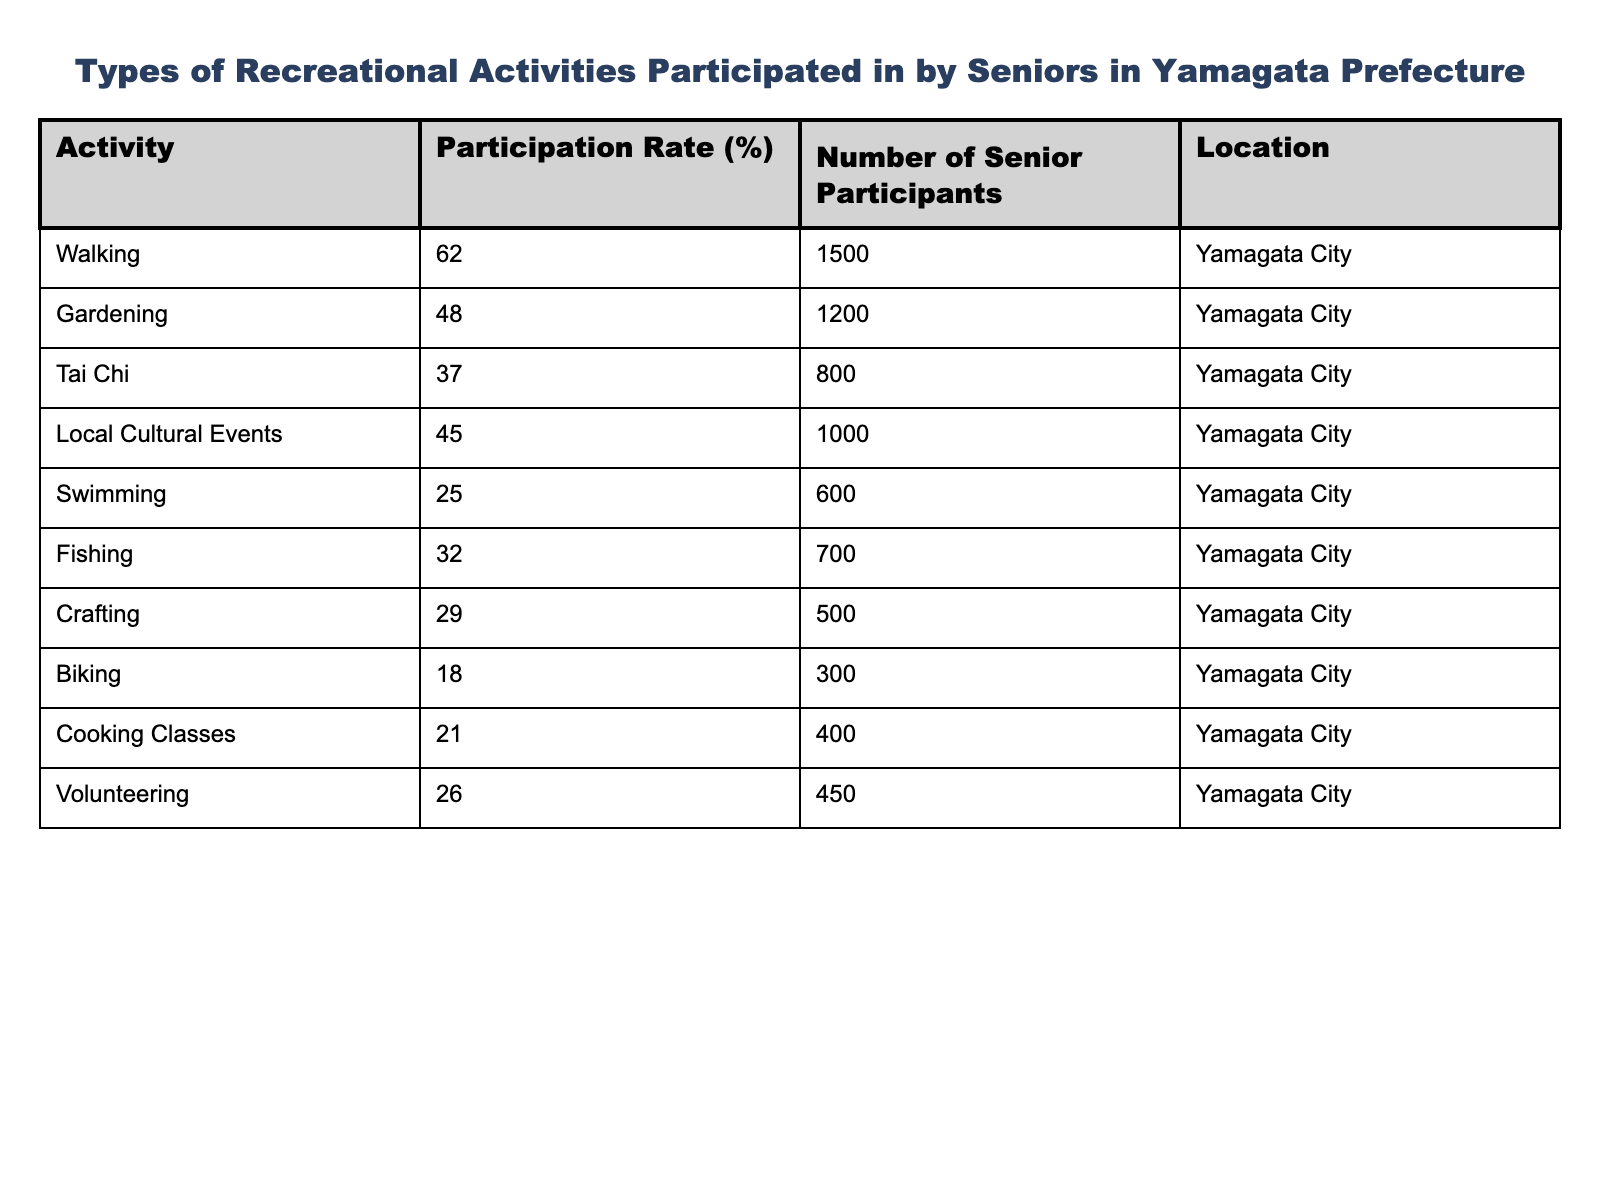What is the most participated activity among seniors in Yamagata Prefecture? By looking at the "Participation Rate (%)" column, the highest percentage is 62% for walking, indicating that it is the most participated activity.
Answer: Walking How many senior participants were there in gardening? The table shows that 1200 seniors participated in gardening, which can be directly found in the "Number of Senior Participants" column for the gardening activity.
Answer: 1200 What is the average participation rate of all listed activities? To calculate the average participation rate, sum all the percentages: 62 + 48 + 37 + 45 + 25 + 32 + 29 + 18 + 21 + 26 =  343. Then divide by the number of activities, which is 10: 343 / 10 = 34.3.
Answer: 34.3 Is the participation rate of Tai Chi higher than that of swimming? The participation rate for Tai Chi is 37% and for swimming is 25%. Since 37% is greater than 25%, the statement is true.
Answer: Yes What is the difference in the number of participants between walking and biking? Walking has 1500 participants and biking has 300 participants. The difference is 1500 - 300 = 1200 participants.
Answer: 1200 Which activities had a participation rate below 30%? By examining the "Participation Rate (%)" column, the activities with rates below 30% are swimming (25%), crafting (29%), and biking (18%).
Answer: Swimming, Crafting, Biking How many more participants are there in local cultural events compared to cooking classes? Local cultural events attracted 1000 participants, while cooking classes had 400 participants. The difference is 1000 - 400 = 600 more participants in local cultural events.
Answer: 600 What percentage of seniors participated in fishing compared to swimming? Fishing had a participation rate of 32% and swimming had a rate of 25%. To compare, 32% - 25% = 7%, meaning fishing has a 7% higher participation rate than swimming.
Answer: 7% If the participation rates are sorted from highest to lowest, what are the top three activities? The rates are sorted as follows: Walking (62%), Gardening (48%), and Local Cultural Events (45%). Therefore, the top three activities are walking, gardening, and local cultural events.
Answer: Walking, Gardening, Local Cultural Events What fraction of the total number of senior participants engaged in Tai Chi? The total number of participants is found by adding all participants: 1500 + 1200 + 800 + 1000 + 600 + 700 + 500 + 300 + 400 + 450 = 6150. The participants of Tai Chi are 800, so the fraction is 800/6150, which can be simplified to approximately 8/61.
Answer: 8/61 